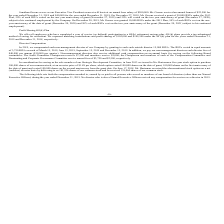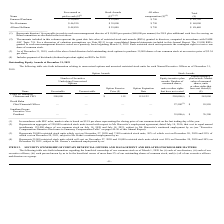According to Network 1 Technologies's financial document, What does Note B[11] detail? discussion of valuation assumptions. The document states: "uted in accordance with FASB ASC Topic 718. For a discussion of valuation assumptions see Note B[11] to our consolidated financial statements included..." Also, Who are the members who served as members of the board of directors (other than Named Executive Officers)? The document contains multiple relevant values: Emanuel Pearlman, Niv Harizman, Alison Hoffman. From the document: "Emanuel Pearlman $ 50,000 $ 39,000 $ 750 $ 89,750 Niv Harizman $ 46,250 $ 39,000 $ 750 $ 86,000..." Also, How much are the directors’ fees payable in cash to each non-management director, per quarter for 2019? According to the financial document, $10,000. The relevant text states: "irectors cash director fees of $40,000 per annum ($10,000 per quarter). Non-management directors also receive additional cash compensation on an annual basis..." Additionally, Which director was compensated the most in 2019? According to the financial document, Emanuel Pearlman. The relevant text states: "Emanuel Pearlman $ 50,000 $ 39,000 $ 750 $ 89,750..." Also, can you calculate: What was the total amount of money received by one audit committee chairperson and one member? Based on the calculation: 7,500+5,000, the result is 12500. This is based on the information: "ompany by granting to each such outside director 15,000 RSUs. The RSUs vested in equal amounts ittees: The Audit Committee Chairperson receives $7,500 and members receive $5,000; the Chairperson and m..." The key data points involved are: 5,000, 7,500. Also, How many directors received compensation of more than $88,000? Counting the relevant items in the document: Emanuel Pearlman, Alison Hoffman, I find 2 instances. The key data points involved are: Alison Hoffman, Emanuel Pearlman. 